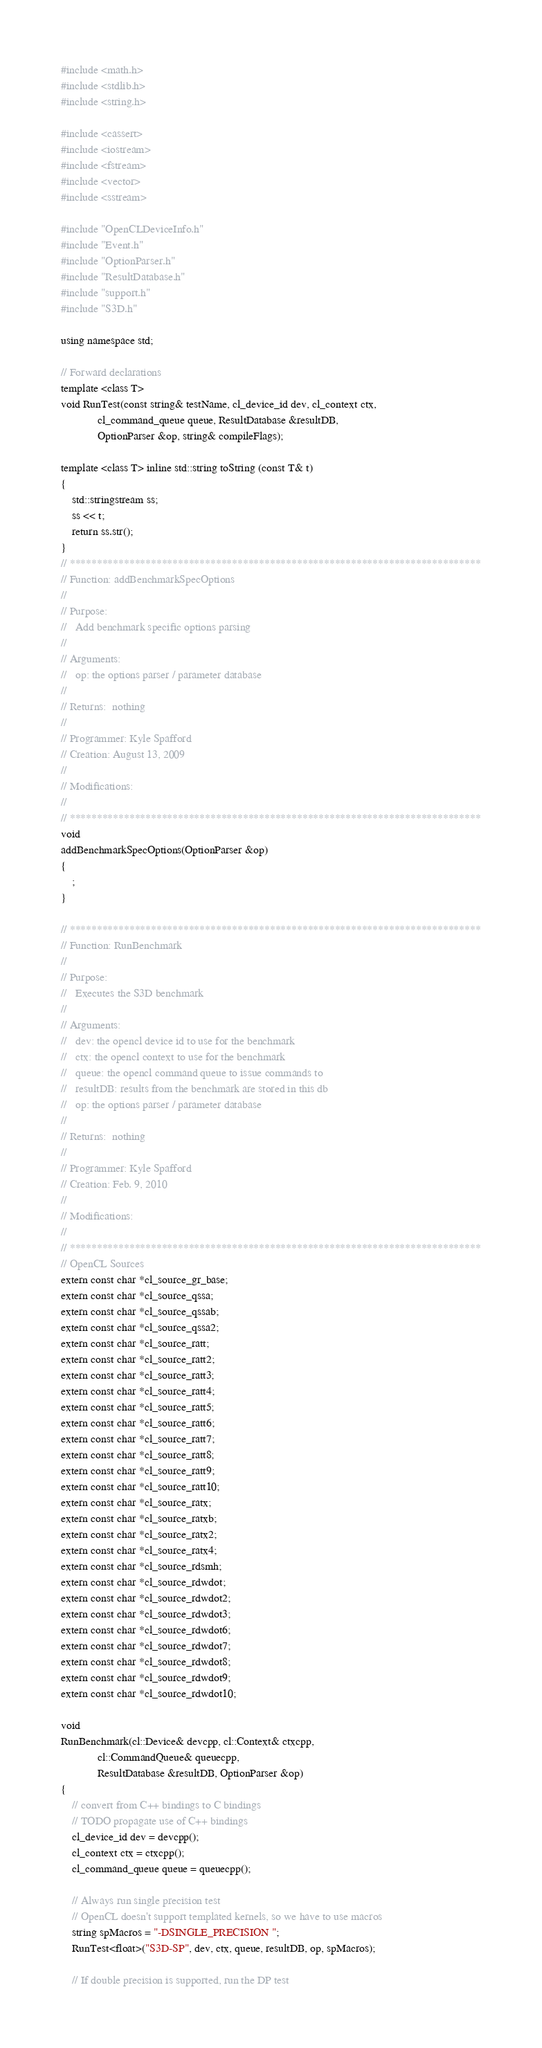<code> <loc_0><loc_0><loc_500><loc_500><_C++_>#include <math.h>
#include <stdlib.h>
#include <string.h>

#include <cassert>
#include <iostream>
#include <fstream>
#include <vector>
#include <sstream>

#include "OpenCLDeviceInfo.h"
#include "Event.h"
#include "OptionParser.h"
#include "ResultDatabase.h"
#include "support.h"
#include "S3D.h"

using namespace std;

// Forward declarations
template <class T>
void RunTest(const string& testName, cl_device_id dev, cl_context ctx,
             cl_command_queue queue, ResultDatabase &resultDB,
             OptionParser &op, string& compileFlags);

template <class T> inline std::string toString (const T& t)
{
    std::stringstream ss;
    ss << t;
    return ss.str();
}
// ****************************************************************************
// Function: addBenchmarkSpecOptions
//
// Purpose:
//   Add benchmark specific options parsing
//
// Arguments:
//   op: the options parser / parameter database
//
// Returns:  nothing
//
// Programmer: Kyle Spafford
// Creation: August 13, 2009
//
// Modifications:
//
// ****************************************************************************
void
addBenchmarkSpecOptions(OptionParser &op)
{
    ;
}

// ****************************************************************************
// Function: RunBenchmark
//
// Purpose:
//   Executes the S3D benchmark
//
// Arguments:
//   dev: the opencl device id to use for the benchmark
//   ctx: the opencl context to use for the benchmark
//   queue: the opencl command queue to issue commands to
//   resultDB: results from the benchmark are stored in this db
//   op: the options parser / parameter database
//
// Returns:  nothing
//
// Programmer: Kyle Spafford
// Creation: Feb. 9, 2010
//
// Modifications:
//
// ****************************************************************************
// OpenCL Sources
extern const char *cl_source_gr_base;
extern const char *cl_source_qssa;
extern const char *cl_source_qssab;
extern const char *cl_source_qssa2;
extern const char *cl_source_ratt;
extern const char *cl_source_ratt2;
extern const char *cl_source_ratt3;
extern const char *cl_source_ratt4;
extern const char *cl_source_ratt5;
extern const char *cl_source_ratt6;
extern const char *cl_source_ratt7;
extern const char *cl_source_ratt8;
extern const char *cl_source_ratt9;
extern const char *cl_source_ratt10;
extern const char *cl_source_ratx;
extern const char *cl_source_ratxb;
extern const char *cl_source_ratx2;
extern const char *cl_source_ratx4;
extern const char *cl_source_rdsmh;
extern const char *cl_source_rdwdot;
extern const char *cl_source_rdwdot2;
extern const char *cl_source_rdwdot3;
extern const char *cl_source_rdwdot6;
extern const char *cl_source_rdwdot7;
extern const char *cl_source_rdwdot8;
extern const char *cl_source_rdwdot9;
extern const char *cl_source_rdwdot10;

void
RunBenchmark(cl::Device& devcpp, cl::Context& ctxcpp, 
             cl::CommandQueue& queuecpp,
             ResultDatabase &resultDB, OptionParser &op)
{
    // convert from C++ bindings to C bindings
    // TODO propagate use of C++ bindings
    cl_device_id dev = devcpp();
    cl_context ctx = ctxcpp();
    cl_command_queue queue = queuecpp();

    // Always run single precision test
    // OpenCL doesn't support templated kernels, so we have to use macros
    string spMacros = "-DSINGLE_PRECISION ";
    RunTest<float>("S3D-SP", dev, ctx, queue, resultDB, op, spMacros);

    // If double precision is supported, run the DP test</code> 